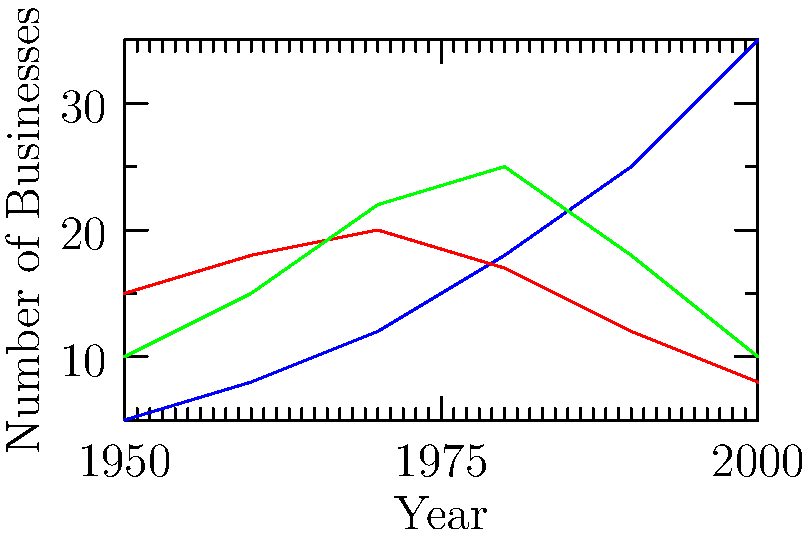Based on the graph showing the number of coffee shops, bookstores, and record stores in the neighborhood from 1950 to 2000, which type of business showed the most consistent growth throughout the entire period? To determine which type of business showed the most consistent growth throughout the entire period, we need to analyze the trends for each business type:

1. Coffee Shops:
   - Started at 5 in 1950
   - Increased steadily each decade
   - Ended at 35 in 2000
   - Shows a consistent upward trend

2. Bookstores:
   - Started at 15 in 1950
   - Increased slightly until 1970
   - Declined from 1970 to 2000
   - Does not show consistent growth

3. Record Stores:
   - Started at 10 in 1950
   - Increased until 1980
   - Declined from 1980 to 2000
   - Does not show consistent growth

Among these three business types, only coffee shops demonstrated consistent growth throughout the entire period from 1950 to 2000. Both bookstores and record stores showed initial growth followed by decline, while coffee shops maintained a steady increase in numbers across all decades.
Answer: Coffee shops 